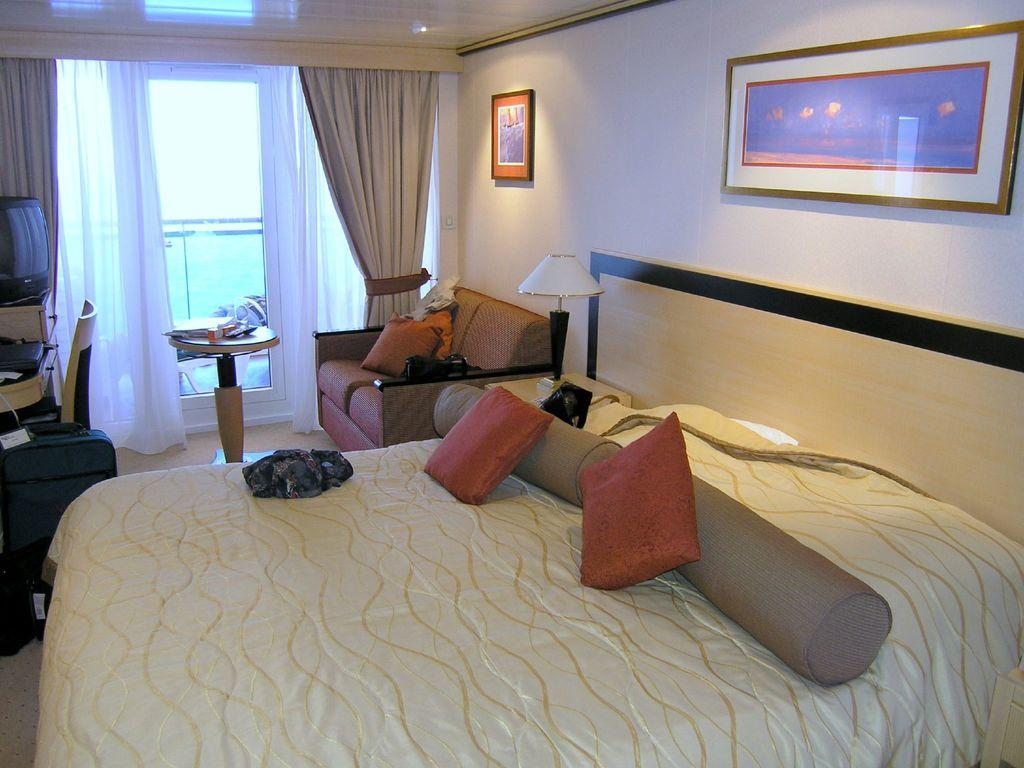What type of furniture is present in the image? There is a bed, a couch, a table, a chair, and a lamp in the image. What is used for support and comfort while sleeping? There is a pillow in the image. What might be used for decoration or to hold objects in the image? There is a frame in the image. What is used to control the amount of light in the room in the image? There is a lamp in the image. What is used to cover or separate areas in the image? There is a curtain in the image. What type of account is being discussed in the image? There is no account being discussed in the image; it features various pieces of furniture and decor. 